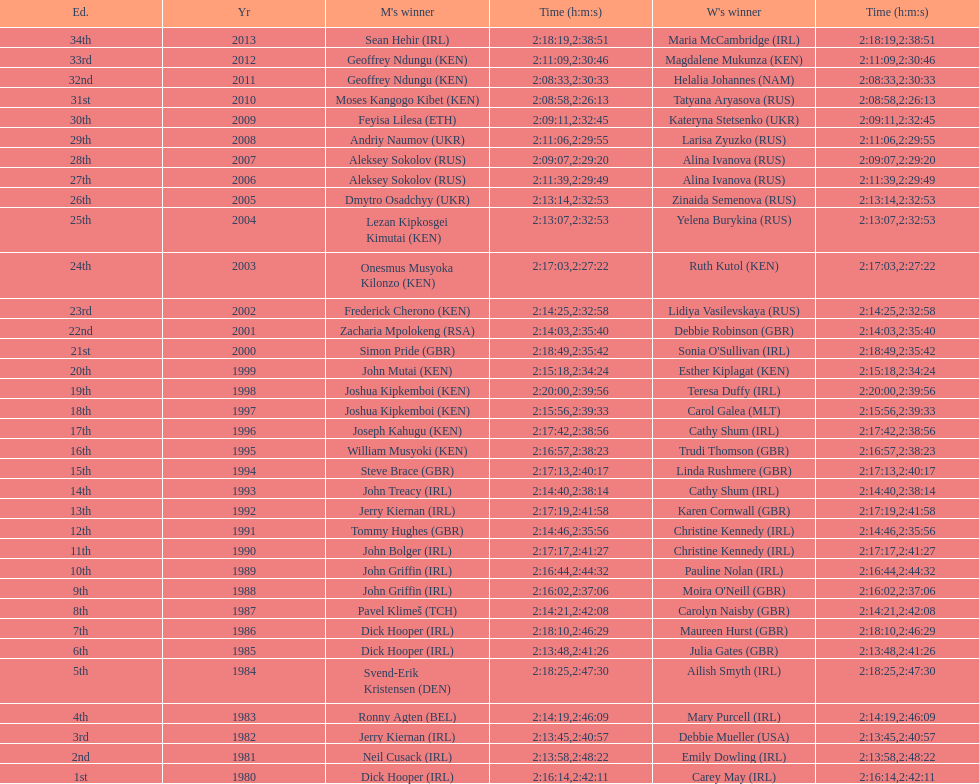Which nation is represented for both males and females at the peak of the list? Ireland. Parse the table in full. {'header': ['Ed.', 'Yr', "M's winner", 'Time (h:m:s)', "W's winner", 'Time (h:m:s)'], 'rows': [['34th', '2013', 'Sean Hehir\xa0(IRL)', '2:18:19', 'Maria McCambridge\xa0(IRL)', '2:38:51'], ['33rd', '2012', 'Geoffrey Ndungu\xa0(KEN)', '2:11:09', 'Magdalene Mukunza\xa0(KEN)', '2:30:46'], ['32nd', '2011', 'Geoffrey Ndungu\xa0(KEN)', '2:08:33', 'Helalia Johannes\xa0(NAM)', '2:30:33'], ['31st', '2010', 'Moses Kangogo Kibet\xa0(KEN)', '2:08:58', 'Tatyana Aryasova\xa0(RUS)', '2:26:13'], ['30th', '2009', 'Feyisa Lilesa\xa0(ETH)', '2:09:11', 'Kateryna Stetsenko\xa0(UKR)', '2:32:45'], ['29th', '2008', 'Andriy Naumov\xa0(UKR)', '2:11:06', 'Larisa Zyuzko\xa0(RUS)', '2:29:55'], ['28th', '2007', 'Aleksey Sokolov\xa0(RUS)', '2:09:07', 'Alina Ivanova\xa0(RUS)', '2:29:20'], ['27th', '2006', 'Aleksey Sokolov\xa0(RUS)', '2:11:39', 'Alina Ivanova\xa0(RUS)', '2:29:49'], ['26th', '2005', 'Dmytro Osadchyy\xa0(UKR)', '2:13:14', 'Zinaida Semenova\xa0(RUS)', '2:32:53'], ['25th', '2004', 'Lezan Kipkosgei Kimutai\xa0(KEN)', '2:13:07', 'Yelena Burykina\xa0(RUS)', '2:32:53'], ['24th', '2003', 'Onesmus Musyoka Kilonzo\xa0(KEN)', '2:17:03', 'Ruth Kutol\xa0(KEN)', '2:27:22'], ['23rd', '2002', 'Frederick Cherono\xa0(KEN)', '2:14:25', 'Lidiya Vasilevskaya\xa0(RUS)', '2:32:58'], ['22nd', '2001', 'Zacharia Mpolokeng\xa0(RSA)', '2:14:03', 'Debbie Robinson\xa0(GBR)', '2:35:40'], ['21st', '2000', 'Simon Pride\xa0(GBR)', '2:18:49', "Sonia O'Sullivan\xa0(IRL)", '2:35:42'], ['20th', '1999', 'John Mutai\xa0(KEN)', '2:15:18', 'Esther Kiplagat\xa0(KEN)', '2:34:24'], ['19th', '1998', 'Joshua Kipkemboi\xa0(KEN)', '2:20:00', 'Teresa Duffy\xa0(IRL)', '2:39:56'], ['18th', '1997', 'Joshua Kipkemboi\xa0(KEN)', '2:15:56', 'Carol Galea\xa0(MLT)', '2:39:33'], ['17th', '1996', 'Joseph Kahugu\xa0(KEN)', '2:17:42', 'Cathy Shum\xa0(IRL)', '2:38:56'], ['16th', '1995', 'William Musyoki\xa0(KEN)', '2:16:57', 'Trudi Thomson\xa0(GBR)', '2:38:23'], ['15th', '1994', 'Steve Brace\xa0(GBR)', '2:17:13', 'Linda Rushmere\xa0(GBR)', '2:40:17'], ['14th', '1993', 'John Treacy\xa0(IRL)', '2:14:40', 'Cathy Shum\xa0(IRL)', '2:38:14'], ['13th', '1992', 'Jerry Kiernan\xa0(IRL)', '2:17:19', 'Karen Cornwall\xa0(GBR)', '2:41:58'], ['12th', '1991', 'Tommy Hughes\xa0(GBR)', '2:14:46', 'Christine Kennedy\xa0(IRL)', '2:35:56'], ['11th', '1990', 'John Bolger\xa0(IRL)', '2:17:17', 'Christine Kennedy\xa0(IRL)', '2:41:27'], ['10th', '1989', 'John Griffin\xa0(IRL)', '2:16:44', 'Pauline Nolan\xa0(IRL)', '2:44:32'], ['9th', '1988', 'John Griffin\xa0(IRL)', '2:16:02', "Moira O'Neill\xa0(GBR)", '2:37:06'], ['8th', '1987', 'Pavel Klimeš\xa0(TCH)', '2:14:21', 'Carolyn Naisby\xa0(GBR)', '2:42:08'], ['7th', '1986', 'Dick Hooper\xa0(IRL)', '2:18:10', 'Maureen Hurst\xa0(GBR)', '2:46:29'], ['6th', '1985', 'Dick Hooper\xa0(IRL)', '2:13:48', 'Julia Gates\xa0(GBR)', '2:41:26'], ['5th', '1984', 'Svend-Erik Kristensen\xa0(DEN)', '2:18:25', 'Ailish Smyth\xa0(IRL)', '2:47:30'], ['4th', '1983', 'Ronny Agten\xa0(BEL)', '2:14:19', 'Mary Purcell\xa0(IRL)', '2:46:09'], ['3rd', '1982', 'Jerry Kiernan\xa0(IRL)', '2:13:45', 'Debbie Mueller\xa0(USA)', '2:40:57'], ['2nd', '1981', 'Neil Cusack\xa0(IRL)', '2:13:58', 'Emily Dowling\xa0(IRL)', '2:48:22'], ['1st', '1980', 'Dick Hooper\xa0(IRL)', '2:16:14', 'Carey May\xa0(IRL)', '2:42:11']]} 